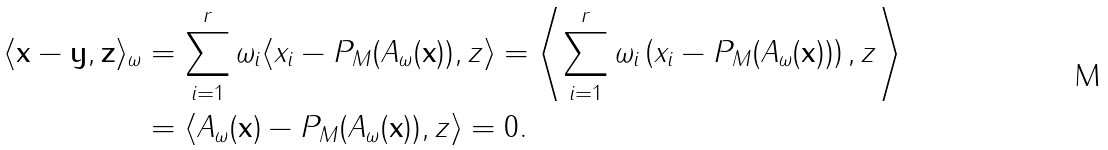<formula> <loc_0><loc_0><loc_500><loc_500>\langle \mathbf x - \mathbf y , \mathbf z \rangle _ { \omega } & = \sum _ { i = 1 } ^ { r } \omega _ { i } \langle x _ { i } - P _ { M } ( A _ { \omega } ( \mathbf x ) ) , z \rangle = \left \langle \sum _ { i = 1 } ^ { r } \omega _ { i } \left ( x _ { i } - P _ { M } ( A _ { \omega } ( \mathbf x ) ) \right ) , z \right \rangle \\ & = \langle A _ { \omega } ( \mathbf x ) - P _ { M } ( A _ { \omega } ( \mathbf x ) ) , z \rangle = 0 .</formula> 